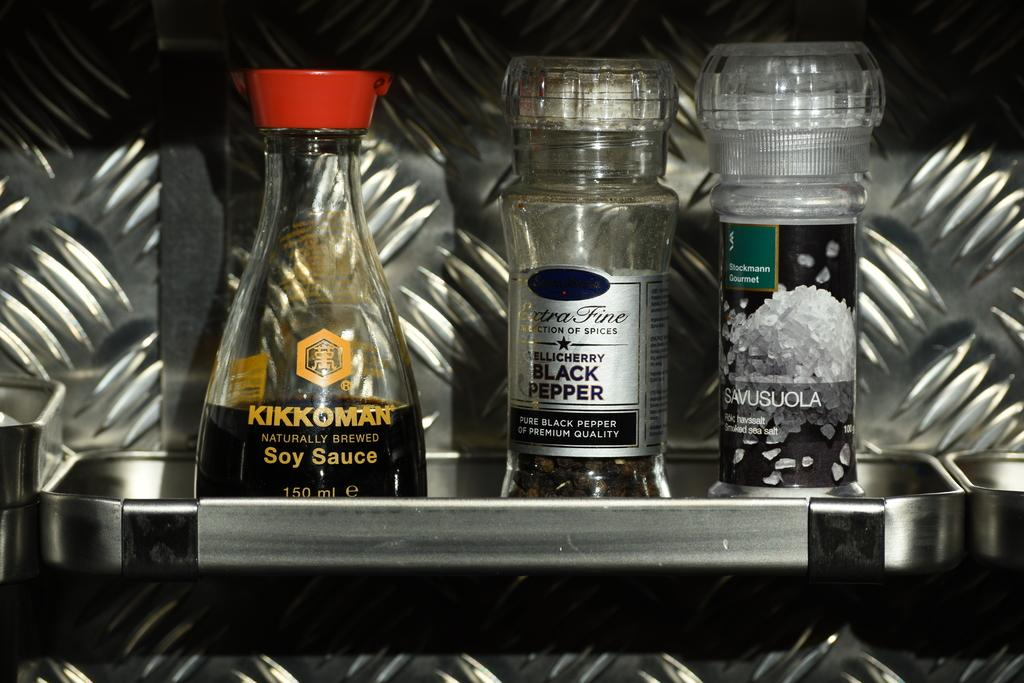How many bottles are visible in the image? There are three bottles in the image. Where are the bottles located? The bottles are in a steel rack. Can you describe any labels on the bottles? There is something written on a label of one or more of the bottles. What type of skirt is hanging on the steel rack in the image? There is no skirt present in the image; it only features bottles in a steel rack. How does the winter season affect the contents of the bottles in the image? The image does not provide any information about the contents of the bottles or the season, so it cannot be determined how the winter season might affect them. 